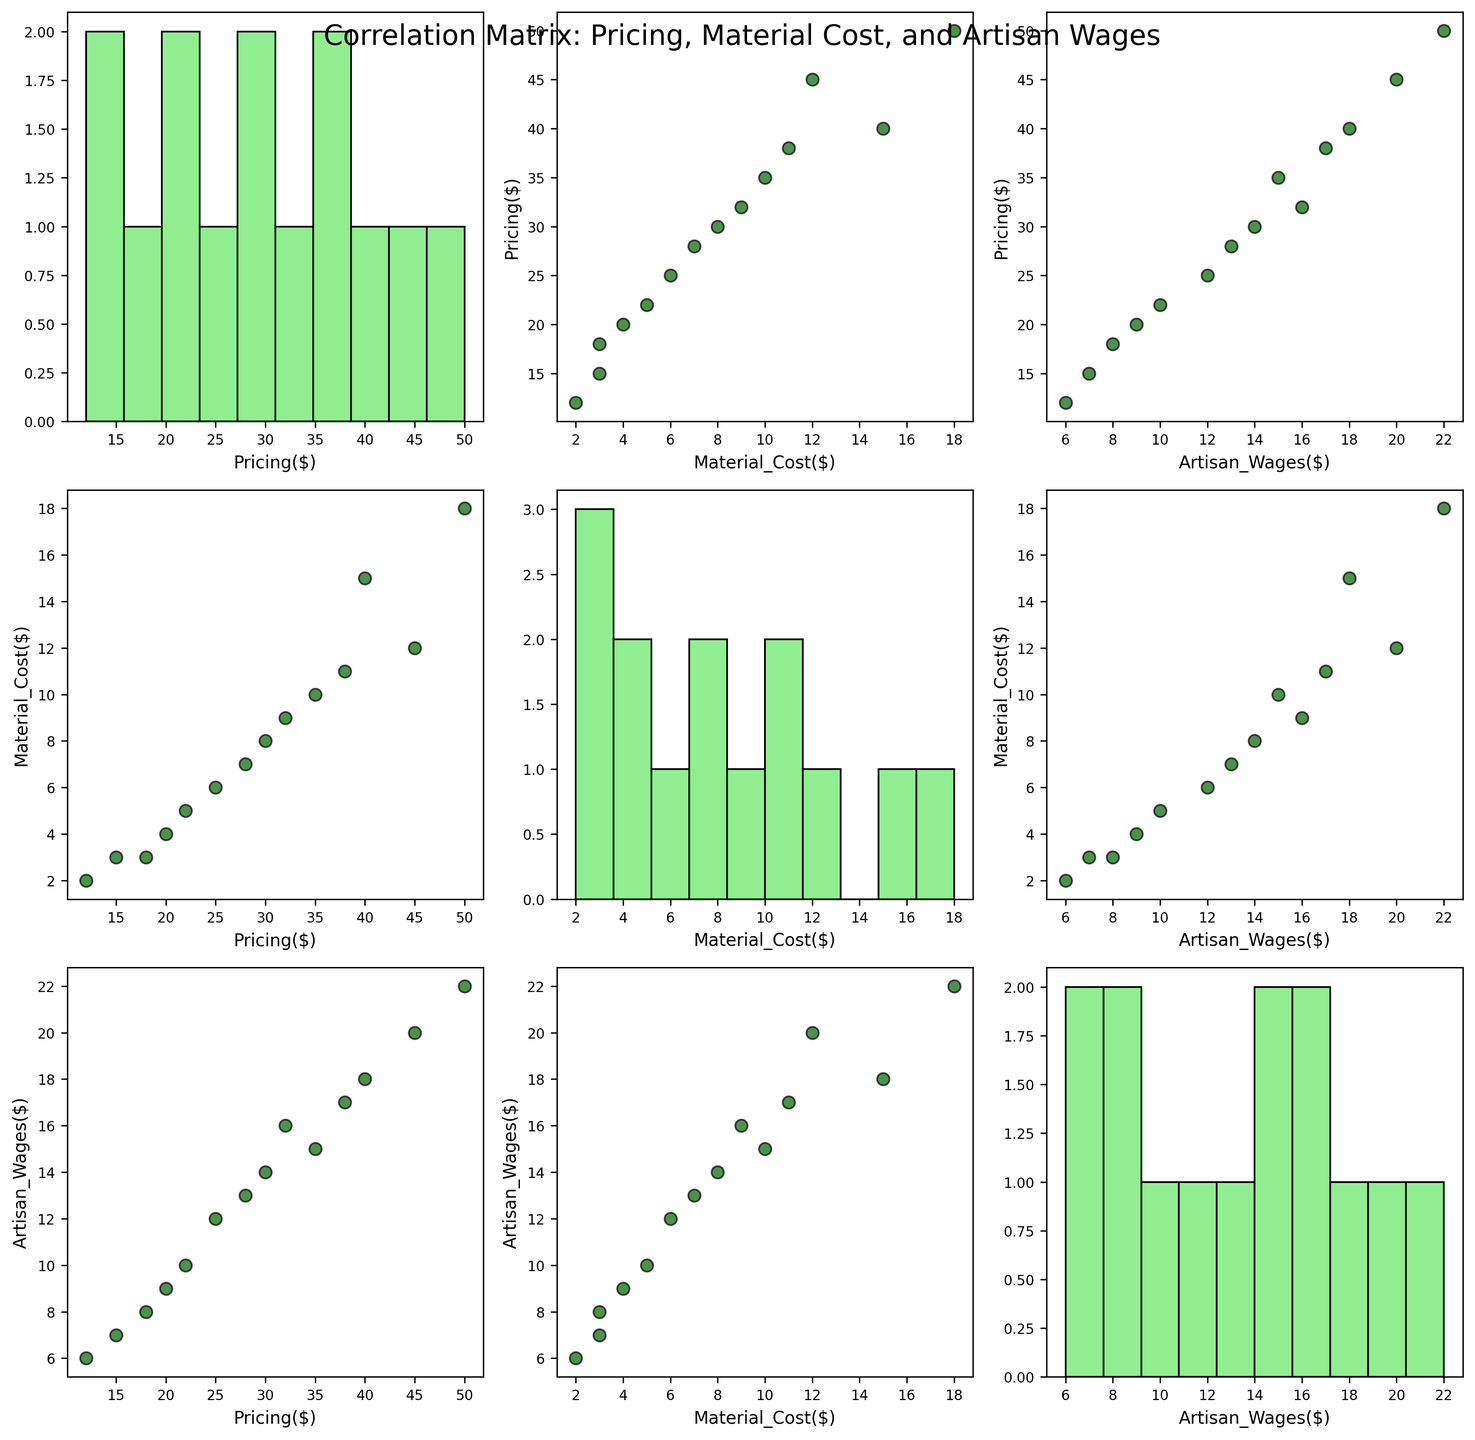what is the title of the figure? The title of the figure is the text displayed at the top. In this case, it clearly states "Correlation Matrix: Pricing, Material Cost, and Artisan Wages".
Answer: Correlation Matrix: Pricing, Material Cost, and Artisan Wages How are the axes labeled in the scatterplot at the first row, second column? The scatterplot in the first row and second column compares "Material_Cost($)" on the x-axis and "Pricing($)" on the y-axis.
Answer: X-axis: Material_Cost($), Y-axis: Pricing($) Describe the color and characteristics of scatter points in the scatterplots. The scatter points in the scatterplots are colored dark green with an alpha transparency of 0.7, giving them a semi-transparent appearance. They also have a black edge and a size of 50.
Answer: Dark green with black edges Which scatterplot shows the relationship between "Material_Cost($)" and "Artisan_Wages($)"? This scatterplot appears where "Material_Cost($)" is on one axis and "Artisan_Wages($)" is on the other. This is located at the second row, third column and third row, second column.
Answer: Second row, third column and third row, second column Considering the histogram at the diagonal element of the second row, which variable does it describe and what is a noticeable feature? The histogram at this position describes "Material_Cost($)" and a noticeable feature is that the cost values are mostly between $2 and $18.
Answer: Material_Cost($). Costs mostly between $2 and $18 How many data points are present in each scatterplot? To find the number of data points, count the scatter points visible in each plot. Since the dataset comprises 14 products, there are 14 data points in each scatterplot.
Answer: 14 Is there an identifiable trend or correlation in the scatterplot comparing "Pricing($)" and "Artisan_Wages($)"? When looking at the scatterplot in the first row, third column and third row, first column, you can notice a positive correlation as higher artisan wages tend to align with higher pricing.
Answer: Positive correlation What can you infer about the relationship between "Pricing($)" and "Material_Cost($)"? Observing the scatterplot in the first row, second column and second row, first column, there seems to be a positive correlation: as material costs increase, pricing also tends to increase.
Answer: Positive correlation What variable does the histogram in the third row, third column represent? The histogram in the third row, third column is placed on the diagonal and thus represents "Artisan_Wages($)".
Answer: Artisan_Wages($) Which scatterplot would help you best understand the impact of the artisan wages on the pricing of the products? The scatterplot in the first row, third column (or third row, first column) shows the relationship between "Artisan_Wages($)" and "Pricing($)", which can help in understanding the impact.
Answer: First row, third column 